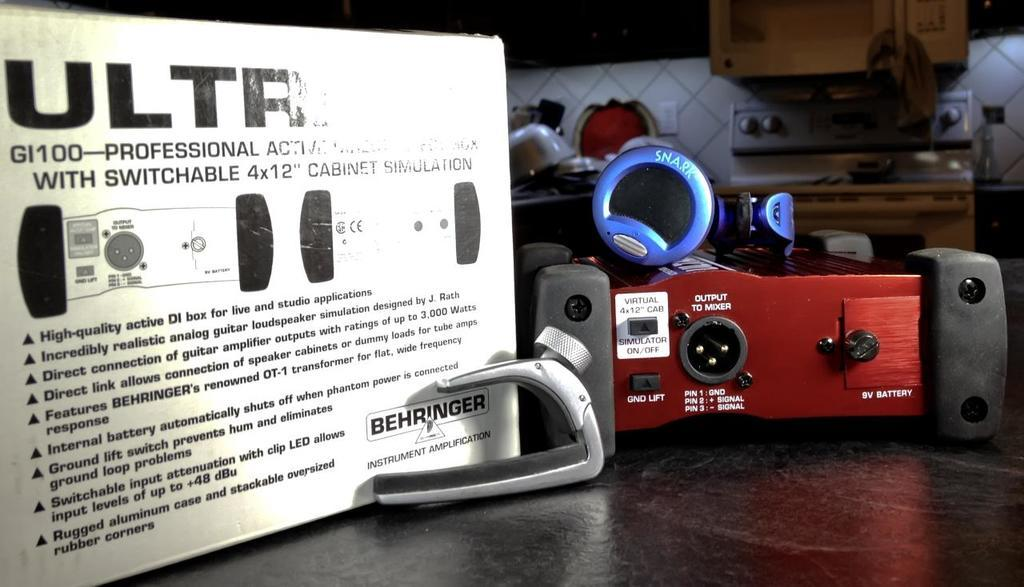Provide a one-sentence caption for the provided image. an ad for ULTR with the equipment on a table. 